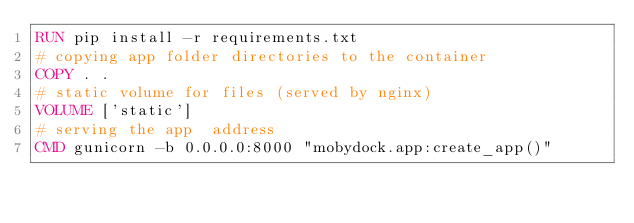Convert code to text. <code><loc_0><loc_0><loc_500><loc_500><_Dockerfile_>RUN pip install -r requirements.txt
# copying app folder directories to the container
COPY . .
# static volume for files (served by nginx)
VOLUME ['static']
# serving the app  address
CMD gunicorn -b 0.0.0.0:8000 "mobydock.app:create_app()"
</code> 